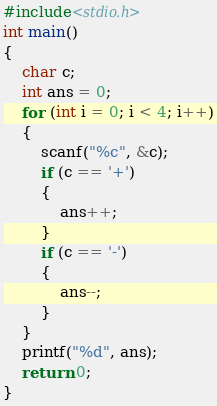<code> <loc_0><loc_0><loc_500><loc_500><_C_>#include<stdio.h>
int main()
{
	char c;
	int ans = 0;
	for (int i = 0; i < 4; i++)
	{
		scanf("%c", &c);
		if (c == '+')
		{
			ans++;
		}
		if (c == '-')
		{
			ans--;
		}
	}
	printf("%d", ans);
	return 0;
}</code> 